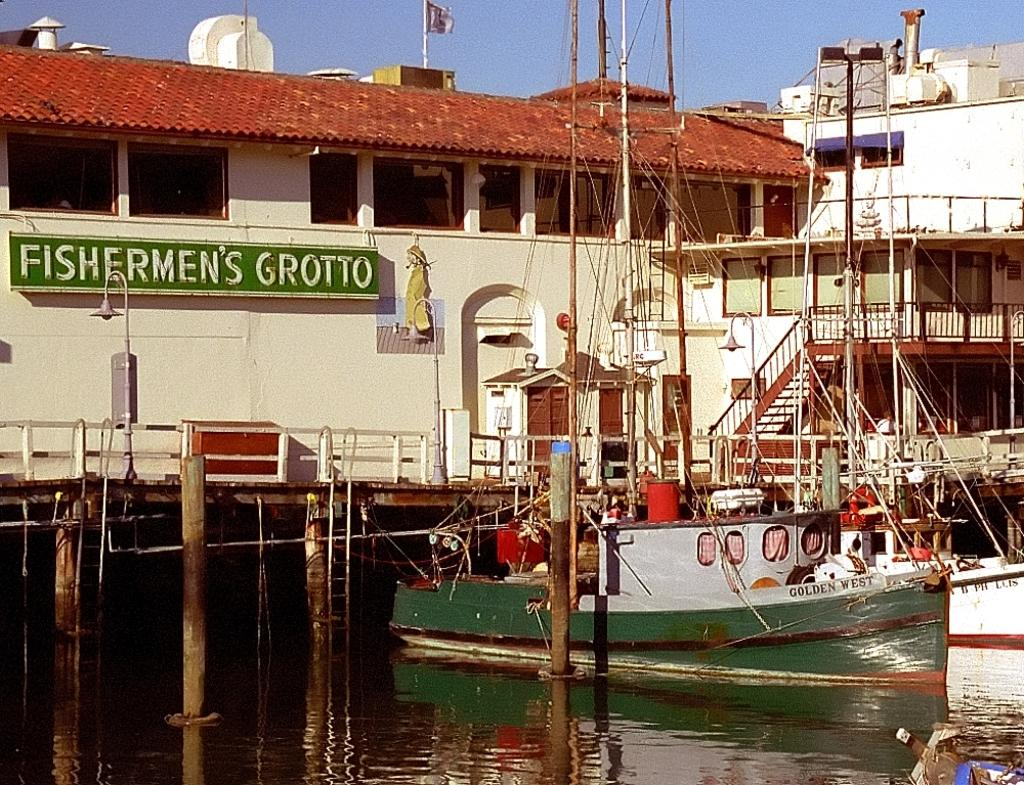<image>
Present a compact description of the photo's key features. A building is adorned with a sign that says Fishermen's Grotto. 